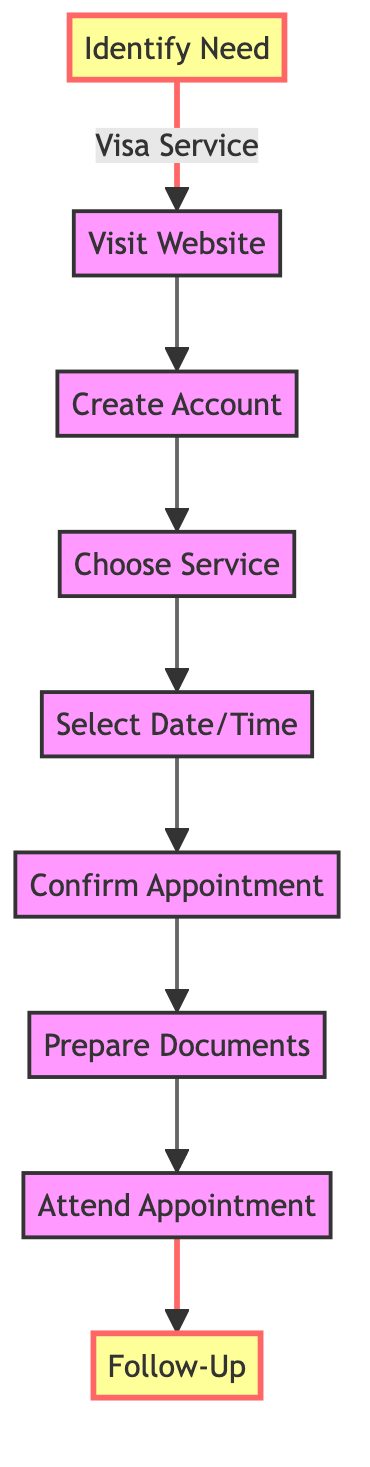What is the first step in obtaining a visa appointment? The first step is "Identify the Need for an Appointment," which involves determining the type of visa service required.
Answer: Identify the Need for an Appointment How many steps are in the flowchart? There are a total of nine steps shown in the flowchart, each representing a crucial part of obtaining a consulate appointment for visa services.
Answer: Nine What step comes after "Select Appointment Date and Time"? The step that comes after "Select Appointment Date and Time" is "Confirm Appointment." This indicates the next action to take after selecting the date and time.
Answer: Confirm Appointment Which step requires gathering all required documents? The step that requires gathering all required documents is "Prepare Required Documents," which specifies the need to collect various documents for the appointment.
Answer: Prepare Required Documents What is the last step in the flowchart? The last step in the flowchart is "Follow-Up (If Necessary)," which suggests tracking the visa application status and responding to any subsequent requests from the consulate.
Answer: Follow-Up (If Necessary) What is the relationship between "Create an Account" and "Visit Official Consulate Website"? The relationship is that "Visit Official Consulate Website" is the preceding step to "Create an Account," meaning you must first visit the website to access the appointment system before creating an account.
Answer: Preceding step What documentation is required for the "Attend Appointment" step? The "Attend Appointment" step requires all necessary documents, such as passport, photographs, application forms, and proof of legal residence in Puducherry, to be physically brought to the consulate.
Answer: All required documents Which step highlights the necessity of confirming your appointment? The step that highlights the necessity of confirming your appointment is "Confirm Appointment," which emphasizes the importance of securing the chosen appointment slot.
Answer: Confirm Appointment What specific action follows "Choose Service Type"? The specific action that follows "Choose Service Type" is "Select Appointment Date and Time," indicating that once the service type is chosen, the next logical step is to schedule the appointment.
Answer: Select Appointment Date and Time 